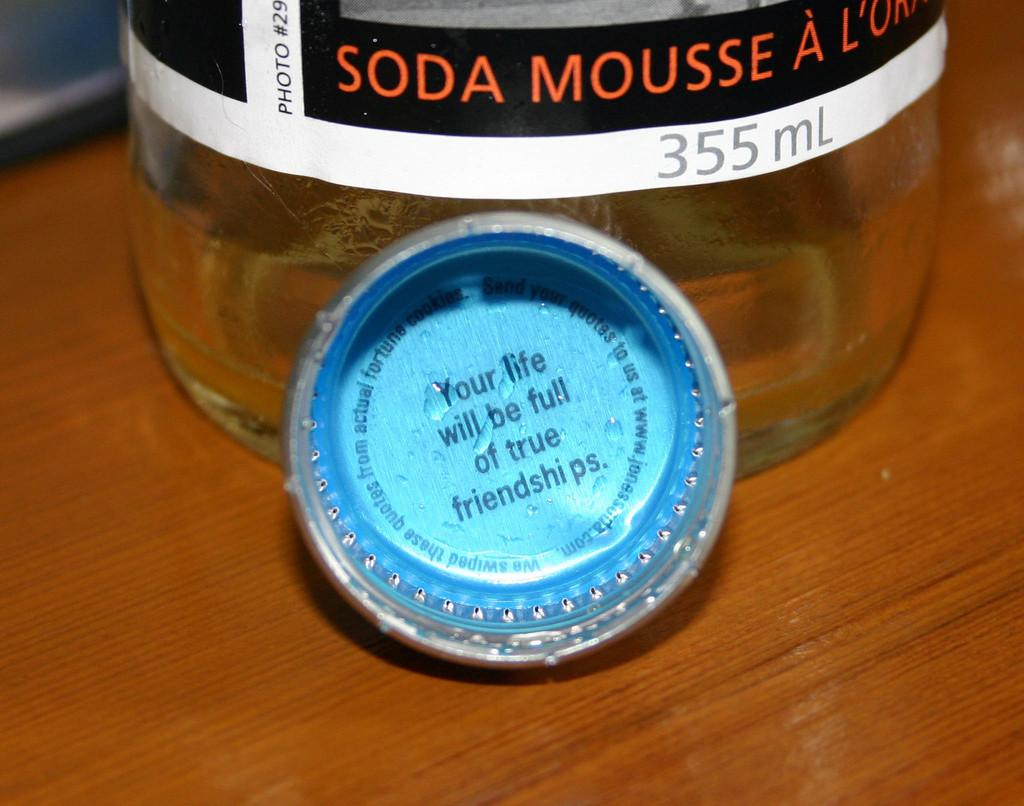<image>
Render a clear and concise summary of the photo. The inside of a cap of a bottle has a saying in it 